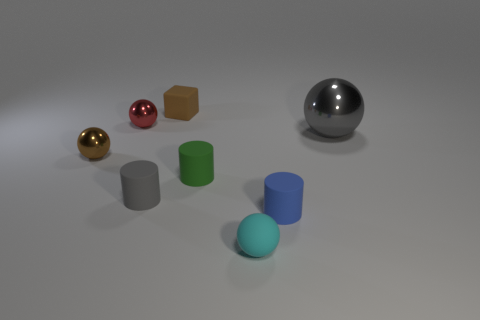Subtract all brown metal balls. How many balls are left? 3 Subtract all green objects. Subtract all gray shiny cubes. How many objects are left? 7 Add 5 tiny green cylinders. How many tiny green cylinders are left? 6 Add 5 large balls. How many large balls exist? 6 Add 2 large yellow metal cubes. How many objects exist? 10 Subtract all cyan spheres. How many spheres are left? 3 Subtract 1 gray cylinders. How many objects are left? 7 Subtract all cubes. How many objects are left? 7 Subtract 2 cylinders. How many cylinders are left? 1 Subtract all purple cylinders. Subtract all brown blocks. How many cylinders are left? 3 